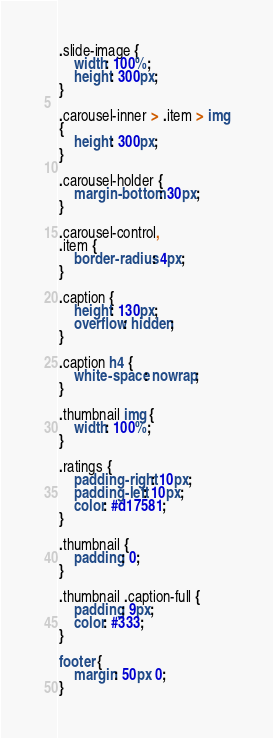<code> <loc_0><loc_0><loc_500><loc_500><_CSS_>.slide-image {
    width: 100%;
    height: 300px;
}

.carousel-inner > .item > img
{
    height: 300px;
}

.carousel-holder {
    margin-bottom: 30px;
}

.carousel-control,
.item {
    border-radius: 4px;
}

.caption {
    height: 130px;
    overflow: hidden;
}

.caption h4 {
    white-space: nowrap;
}

.thumbnail img {
    width: 100%;
}

.ratings {
    padding-right: 10px;
    padding-left: 10px;
    color: #d17581;
}

.thumbnail {
    padding: 0;
}

.thumbnail .caption-full {
    padding: 9px;
    color: #333;
}

footer {
    margin: 50px 0;
}</code> 